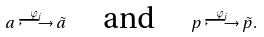Convert formula to latex. <formula><loc_0><loc_0><loc_500><loc_500>a \stackrel { \varphi _ { i } } { \longmapsto } \tilde { a } \quad \text { and } \quad p \stackrel { \varphi _ { i } } { \longmapsto } \tilde { p } .</formula> 